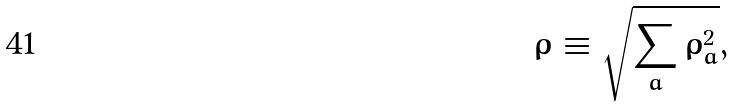Convert formula to latex. <formula><loc_0><loc_0><loc_500><loc_500>\rho \equiv \sqrt { \sum _ { a } \rho _ { a } ^ { 2 } } ,</formula> 